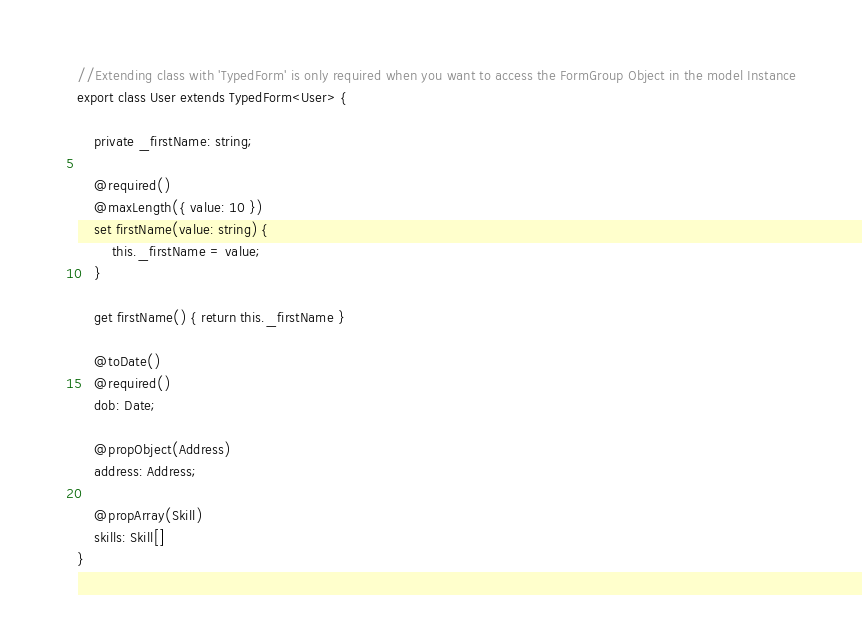Convert code to text. <code><loc_0><loc_0><loc_500><loc_500><_TypeScript_>//Extending class with 'TypedForm' is only required when you want to access the FormGroup Object in the model Instance
export class User extends TypedForm<User> {

    private _firstName: string;

    @required()
    @maxLength({ value: 10 })
    set firstName(value: string) {
        this._firstName = value;
    }

    get firstName() { return this._firstName }

    @toDate()
    @required()
    dob: Date;

    @propObject(Address)
    address: Address;

    @propArray(Skill)
    skills: Skill[]
}
</code> 